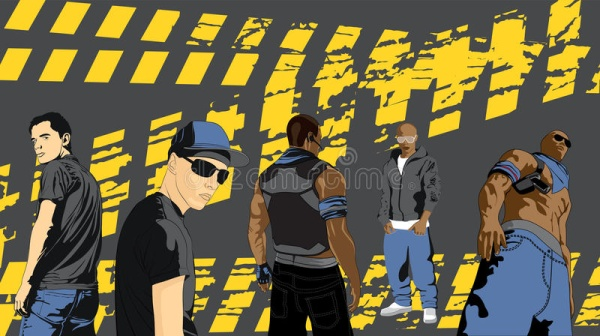If each character had a superpower, what would they be? If each character in the image had a superpower, they would bring even more dynamism to their personas. The man on the far left, with his confident stance, could have the power of unyielding strength, capable of lifting and breaking any barrier. The second man from the left, with his assertive gaze, could possess the ability to manipulate shadows, using them to cloak and deceive. The central figure, with his back turned, might have the power of invisibility, allowing him to slip away unnoticed. The man in the gray hoodie could have the ability to manipulate time, pausing or rewinding moments to his advantage. Lastly, the muscular man on the far right could have the power of invincibility, rendering him immune to any physical harm. 